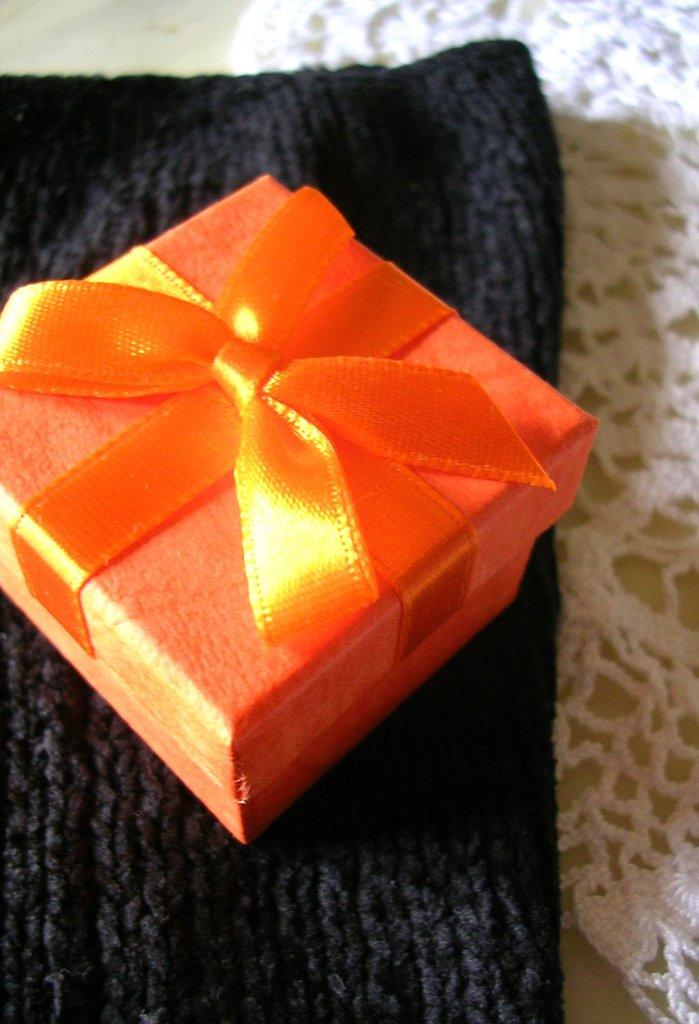What is the main object in the image? There is a gift in the image. How is the gift prepared? The gift is packed. What is the gift placed on? The gift is placed on woolen clothes. What type of noise can be heard coming from the grandmother in the image? There is no grandmother present in the image, so it is not possible to determine what, if any, noise might be heard. 